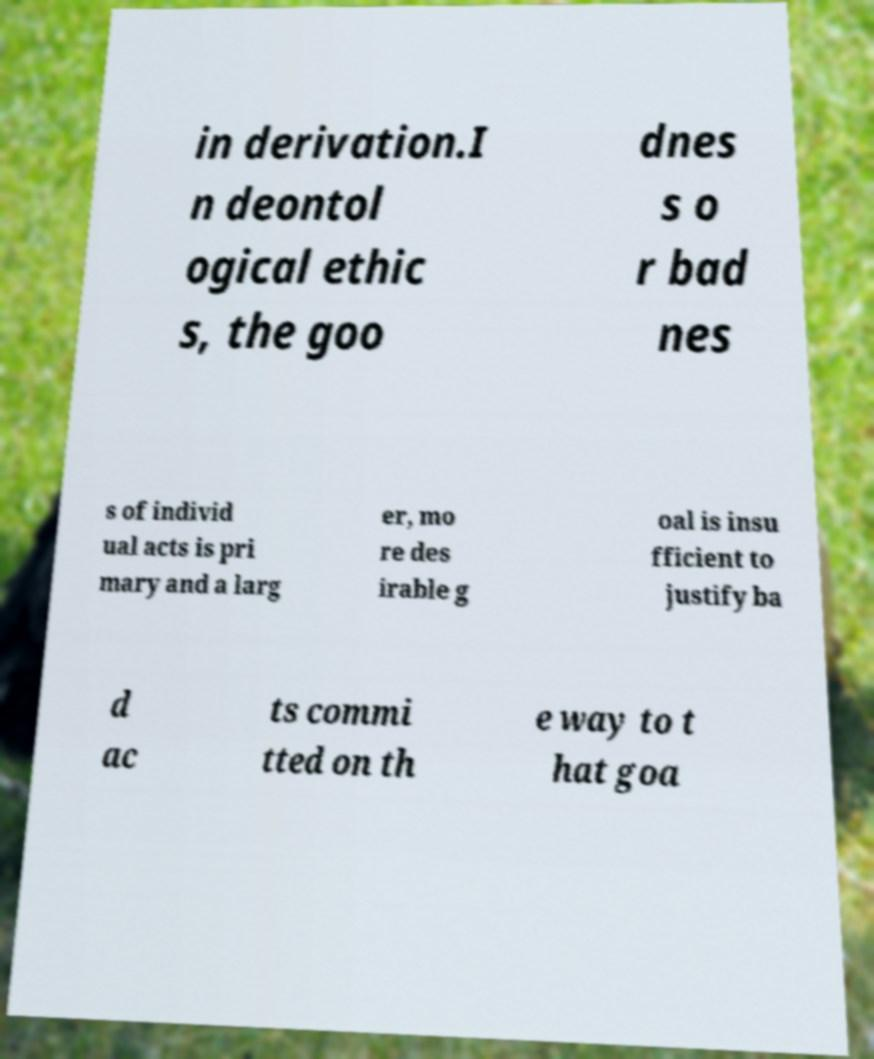I need the written content from this picture converted into text. Can you do that? in derivation.I n deontol ogical ethic s, the goo dnes s o r bad nes s of individ ual acts is pri mary and a larg er, mo re des irable g oal is insu fficient to justify ba d ac ts commi tted on th e way to t hat goa 